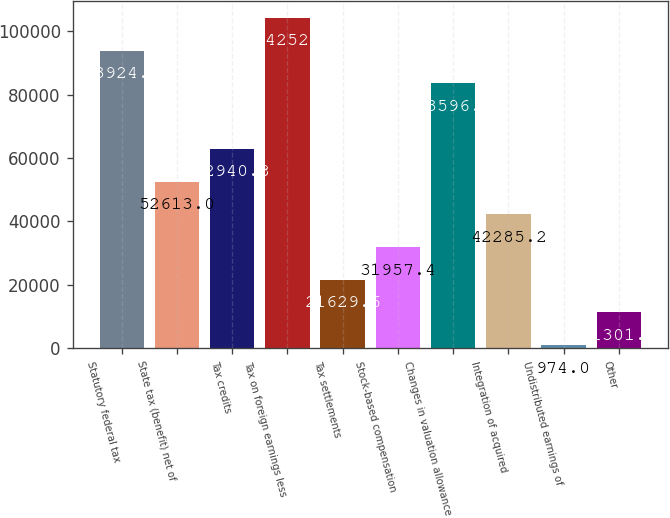<chart> <loc_0><loc_0><loc_500><loc_500><bar_chart><fcel>Statutory federal tax<fcel>State tax (benefit) net of<fcel>Tax credits<fcel>Tax on foreign earnings less<fcel>Tax settlements<fcel>Stock-based compensation<fcel>Changes in valuation allowance<fcel>Integration of acquired<fcel>Undistributed earnings of<fcel>Other<nl><fcel>93924.2<fcel>52613<fcel>62940.8<fcel>104252<fcel>21629.6<fcel>31957.4<fcel>83596.4<fcel>42285.2<fcel>974<fcel>11301.8<nl></chart> 